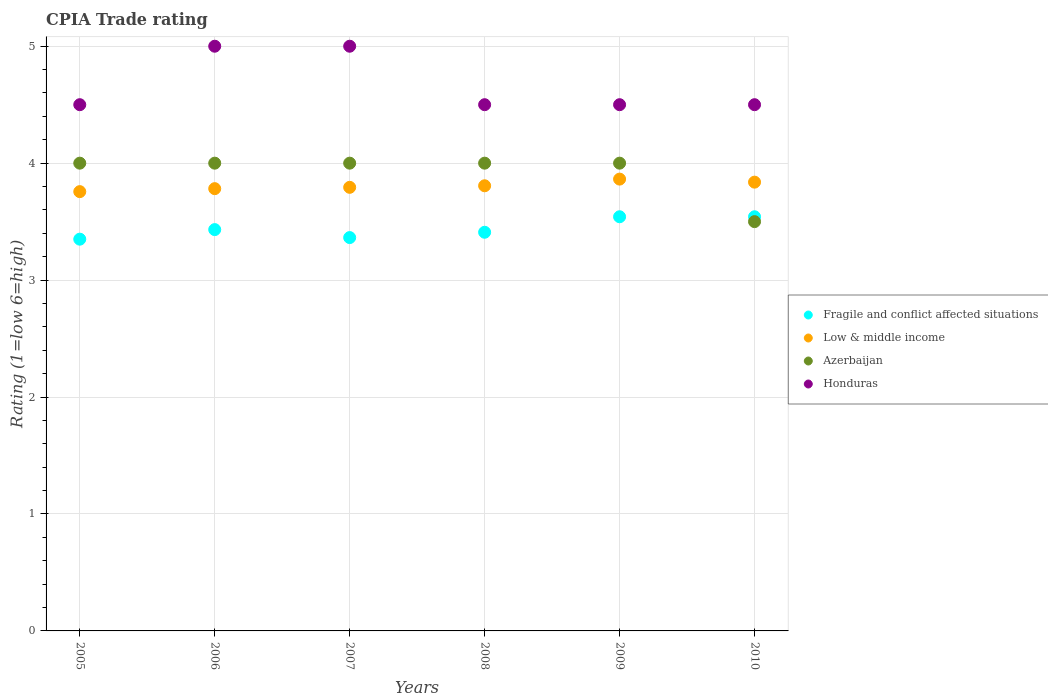How many different coloured dotlines are there?
Your answer should be very brief. 4. Is the number of dotlines equal to the number of legend labels?
Keep it short and to the point. Yes. Across all years, what is the maximum CPIA rating in Low & middle income?
Make the answer very short. 3.86. Across all years, what is the minimum CPIA rating in Low & middle income?
Your answer should be compact. 3.76. In which year was the CPIA rating in Fragile and conflict affected situations maximum?
Provide a succinct answer. 2009. What is the total CPIA rating in Low & middle income in the graph?
Provide a short and direct response. 22.84. What is the difference between the CPIA rating in Low & middle income in 2009 and that in 2010?
Offer a very short reply. 0.03. What is the difference between the CPIA rating in Azerbaijan in 2005 and the CPIA rating in Low & middle income in 2010?
Your answer should be very brief. 0.16. What is the average CPIA rating in Fragile and conflict affected situations per year?
Ensure brevity in your answer.  3.44. In the year 2008, what is the difference between the CPIA rating in Azerbaijan and CPIA rating in Honduras?
Keep it short and to the point. -0.5. What is the ratio of the CPIA rating in Low & middle income in 2006 to that in 2010?
Provide a succinct answer. 0.99. Is the CPIA rating in Low & middle income in 2008 less than that in 2009?
Your answer should be very brief. Yes. Is the difference between the CPIA rating in Azerbaijan in 2006 and 2007 greater than the difference between the CPIA rating in Honduras in 2006 and 2007?
Provide a succinct answer. No. In how many years, is the CPIA rating in Low & middle income greater than the average CPIA rating in Low & middle income taken over all years?
Provide a short and direct response. 3. Is it the case that in every year, the sum of the CPIA rating in Honduras and CPIA rating in Azerbaijan  is greater than the sum of CPIA rating in Fragile and conflict affected situations and CPIA rating in Low & middle income?
Keep it short and to the point. No. Is it the case that in every year, the sum of the CPIA rating in Fragile and conflict affected situations and CPIA rating in Azerbaijan  is greater than the CPIA rating in Honduras?
Make the answer very short. Yes. Does the CPIA rating in Honduras monotonically increase over the years?
Provide a short and direct response. No. How many dotlines are there?
Your answer should be very brief. 4. How many years are there in the graph?
Your answer should be very brief. 6. What is the difference between two consecutive major ticks on the Y-axis?
Ensure brevity in your answer.  1. How many legend labels are there?
Provide a succinct answer. 4. How are the legend labels stacked?
Your answer should be very brief. Vertical. What is the title of the graph?
Keep it short and to the point. CPIA Trade rating. Does "Denmark" appear as one of the legend labels in the graph?
Offer a terse response. No. What is the Rating (1=low 6=high) in Fragile and conflict affected situations in 2005?
Ensure brevity in your answer.  3.35. What is the Rating (1=low 6=high) of Low & middle income in 2005?
Your answer should be compact. 3.76. What is the Rating (1=low 6=high) in Azerbaijan in 2005?
Your answer should be compact. 4. What is the Rating (1=low 6=high) of Honduras in 2005?
Your answer should be compact. 4.5. What is the Rating (1=low 6=high) of Fragile and conflict affected situations in 2006?
Offer a very short reply. 3.43. What is the Rating (1=low 6=high) in Low & middle income in 2006?
Provide a succinct answer. 3.78. What is the Rating (1=low 6=high) of Honduras in 2006?
Provide a succinct answer. 5. What is the Rating (1=low 6=high) of Fragile and conflict affected situations in 2007?
Your answer should be very brief. 3.36. What is the Rating (1=low 6=high) in Low & middle income in 2007?
Your answer should be very brief. 3.79. What is the Rating (1=low 6=high) of Honduras in 2007?
Your answer should be compact. 5. What is the Rating (1=low 6=high) in Fragile and conflict affected situations in 2008?
Offer a terse response. 3.41. What is the Rating (1=low 6=high) of Low & middle income in 2008?
Provide a short and direct response. 3.81. What is the Rating (1=low 6=high) of Azerbaijan in 2008?
Ensure brevity in your answer.  4. What is the Rating (1=low 6=high) in Honduras in 2008?
Keep it short and to the point. 4.5. What is the Rating (1=low 6=high) of Fragile and conflict affected situations in 2009?
Provide a succinct answer. 3.54. What is the Rating (1=low 6=high) in Low & middle income in 2009?
Give a very brief answer. 3.86. What is the Rating (1=low 6=high) in Azerbaijan in 2009?
Keep it short and to the point. 4. What is the Rating (1=low 6=high) in Fragile and conflict affected situations in 2010?
Ensure brevity in your answer.  3.54. What is the Rating (1=low 6=high) in Low & middle income in 2010?
Ensure brevity in your answer.  3.84. What is the Rating (1=low 6=high) in Azerbaijan in 2010?
Give a very brief answer. 3.5. Across all years, what is the maximum Rating (1=low 6=high) in Fragile and conflict affected situations?
Give a very brief answer. 3.54. Across all years, what is the maximum Rating (1=low 6=high) of Low & middle income?
Your response must be concise. 3.86. Across all years, what is the maximum Rating (1=low 6=high) of Azerbaijan?
Your answer should be very brief. 4. Across all years, what is the minimum Rating (1=low 6=high) of Fragile and conflict affected situations?
Make the answer very short. 3.35. Across all years, what is the minimum Rating (1=low 6=high) of Low & middle income?
Make the answer very short. 3.76. Across all years, what is the minimum Rating (1=low 6=high) in Azerbaijan?
Ensure brevity in your answer.  3.5. Across all years, what is the minimum Rating (1=low 6=high) in Honduras?
Your answer should be very brief. 4.5. What is the total Rating (1=low 6=high) of Fragile and conflict affected situations in the graph?
Offer a terse response. 20.64. What is the total Rating (1=low 6=high) of Low & middle income in the graph?
Provide a short and direct response. 22.84. What is the total Rating (1=low 6=high) in Azerbaijan in the graph?
Provide a succinct answer. 23.5. What is the total Rating (1=low 6=high) in Honduras in the graph?
Your answer should be compact. 28. What is the difference between the Rating (1=low 6=high) in Fragile and conflict affected situations in 2005 and that in 2006?
Provide a short and direct response. -0.08. What is the difference between the Rating (1=low 6=high) in Low & middle income in 2005 and that in 2006?
Make the answer very short. -0.03. What is the difference between the Rating (1=low 6=high) of Azerbaijan in 2005 and that in 2006?
Provide a short and direct response. 0. What is the difference between the Rating (1=low 6=high) of Fragile and conflict affected situations in 2005 and that in 2007?
Your answer should be compact. -0.01. What is the difference between the Rating (1=low 6=high) in Low & middle income in 2005 and that in 2007?
Ensure brevity in your answer.  -0.04. What is the difference between the Rating (1=low 6=high) in Honduras in 2005 and that in 2007?
Provide a succinct answer. -0.5. What is the difference between the Rating (1=low 6=high) of Fragile and conflict affected situations in 2005 and that in 2008?
Offer a very short reply. -0.06. What is the difference between the Rating (1=low 6=high) in Low & middle income in 2005 and that in 2008?
Offer a terse response. -0.05. What is the difference between the Rating (1=low 6=high) in Honduras in 2005 and that in 2008?
Make the answer very short. 0. What is the difference between the Rating (1=low 6=high) of Fragile and conflict affected situations in 2005 and that in 2009?
Give a very brief answer. -0.19. What is the difference between the Rating (1=low 6=high) in Low & middle income in 2005 and that in 2009?
Offer a very short reply. -0.11. What is the difference between the Rating (1=low 6=high) of Azerbaijan in 2005 and that in 2009?
Offer a very short reply. 0. What is the difference between the Rating (1=low 6=high) of Fragile and conflict affected situations in 2005 and that in 2010?
Your answer should be compact. -0.19. What is the difference between the Rating (1=low 6=high) of Low & middle income in 2005 and that in 2010?
Your response must be concise. -0.08. What is the difference between the Rating (1=low 6=high) in Azerbaijan in 2005 and that in 2010?
Provide a short and direct response. 0.5. What is the difference between the Rating (1=low 6=high) of Fragile and conflict affected situations in 2006 and that in 2007?
Give a very brief answer. 0.07. What is the difference between the Rating (1=low 6=high) of Low & middle income in 2006 and that in 2007?
Your response must be concise. -0.01. What is the difference between the Rating (1=low 6=high) of Azerbaijan in 2006 and that in 2007?
Your answer should be very brief. 0. What is the difference between the Rating (1=low 6=high) in Honduras in 2006 and that in 2007?
Ensure brevity in your answer.  0. What is the difference between the Rating (1=low 6=high) of Fragile and conflict affected situations in 2006 and that in 2008?
Offer a very short reply. 0.02. What is the difference between the Rating (1=low 6=high) in Low & middle income in 2006 and that in 2008?
Offer a very short reply. -0.02. What is the difference between the Rating (1=low 6=high) of Fragile and conflict affected situations in 2006 and that in 2009?
Your response must be concise. -0.11. What is the difference between the Rating (1=low 6=high) of Low & middle income in 2006 and that in 2009?
Ensure brevity in your answer.  -0.08. What is the difference between the Rating (1=low 6=high) in Azerbaijan in 2006 and that in 2009?
Offer a very short reply. 0. What is the difference between the Rating (1=low 6=high) of Fragile and conflict affected situations in 2006 and that in 2010?
Make the answer very short. -0.11. What is the difference between the Rating (1=low 6=high) in Low & middle income in 2006 and that in 2010?
Offer a very short reply. -0.06. What is the difference between the Rating (1=low 6=high) of Azerbaijan in 2006 and that in 2010?
Offer a terse response. 0.5. What is the difference between the Rating (1=low 6=high) in Honduras in 2006 and that in 2010?
Provide a succinct answer. 0.5. What is the difference between the Rating (1=low 6=high) in Fragile and conflict affected situations in 2007 and that in 2008?
Your answer should be very brief. -0.05. What is the difference between the Rating (1=low 6=high) of Low & middle income in 2007 and that in 2008?
Your response must be concise. -0.01. What is the difference between the Rating (1=low 6=high) in Fragile and conflict affected situations in 2007 and that in 2009?
Offer a terse response. -0.18. What is the difference between the Rating (1=low 6=high) in Low & middle income in 2007 and that in 2009?
Your response must be concise. -0.07. What is the difference between the Rating (1=low 6=high) of Azerbaijan in 2007 and that in 2009?
Provide a short and direct response. 0. What is the difference between the Rating (1=low 6=high) of Honduras in 2007 and that in 2009?
Offer a terse response. 0.5. What is the difference between the Rating (1=low 6=high) in Fragile and conflict affected situations in 2007 and that in 2010?
Offer a terse response. -0.18. What is the difference between the Rating (1=low 6=high) in Low & middle income in 2007 and that in 2010?
Make the answer very short. -0.04. What is the difference between the Rating (1=low 6=high) in Fragile and conflict affected situations in 2008 and that in 2009?
Provide a short and direct response. -0.13. What is the difference between the Rating (1=low 6=high) in Low & middle income in 2008 and that in 2009?
Offer a terse response. -0.06. What is the difference between the Rating (1=low 6=high) in Azerbaijan in 2008 and that in 2009?
Keep it short and to the point. 0. What is the difference between the Rating (1=low 6=high) in Fragile and conflict affected situations in 2008 and that in 2010?
Keep it short and to the point. -0.13. What is the difference between the Rating (1=low 6=high) of Low & middle income in 2008 and that in 2010?
Offer a terse response. -0.03. What is the difference between the Rating (1=low 6=high) in Fragile and conflict affected situations in 2009 and that in 2010?
Offer a terse response. 0. What is the difference between the Rating (1=low 6=high) in Low & middle income in 2009 and that in 2010?
Offer a terse response. 0.03. What is the difference between the Rating (1=low 6=high) in Fragile and conflict affected situations in 2005 and the Rating (1=low 6=high) in Low & middle income in 2006?
Keep it short and to the point. -0.43. What is the difference between the Rating (1=low 6=high) of Fragile and conflict affected situations in 2005 and the Rating (1=low 6=high) of Azerbaijan in 2006?
Offer a very short reply. -0.65. What is the difference between the Rating (1=low 6=high) of Fragile and conflict affected situations in 2005 and the Rating (1=low 6=high) of Honduras in 2006?
Your answer should be compact. -1.65. What is the difference between the Rating (1=low 6=high) of Low & middle income in 2005 and the Rating (1=low 6=high) of Azerbaijan in 2006?
Your answer should be compact. -0.24. What is the difference between the Rating (1=low 6=high) of Low & middle income in 2005 and the Rating (1=low 6=high) of Honduras in 2006?
Offer a very short reply. -1.24. What is the difference between the Rating (1=low 6=high) of Azerbaijan in 2005 and the Rating (1=low 6=high) of Honduras in 2006?
Provide a short and direct response. -1. What is the difference between the Rating (1=low 6=high) of Fragile and conflict affected situations in 2005 and the Rating (1=low 6=high) of Low & middle income in 2007?
Ensure brevity in your answer.  -0.44. What is the difference between the Rating (1=low 6=high) of Fragile and conflict affected situations in 2005 and the Rating (1=low 6=high) of Azerbaijan in 2007?
Provide a short and direct response. -0.65. What is the difference between the Rating (1=low 6=high) in Fragile and conflict affected situations in 2005 and the Rating (1=low 6=high) in Honduras in 2007?
Your response must be concise. -1.65. What is the difference between the Rating (1=low 6=high) of Low & middle income in 2005 and the Rating (1=low 6=high) of Azerbaijan in 2007?
Keep it short and to the point. -0.24. What is the difference between the Rating (1=low 6=high) of Low & middle income in 2005 and the Rating (1=low 6=high) of Honduras in 2007?
Provide a short and direct response. -1.24. What is the difference between the Rating (1=low 6=high) in Azerbaijan in 2005 and the Rating (1=low 6=high) in Honduras in 2007?
Your response must be concise. -1. What is the difference between the Rating (1=low 6=high) of Fragile and conflict affected situations in 2005 and the Rating (1=low 6=high) of Low & middle income in 2008?
Provide a short and direct response. -0.46. What is the difference between the Rating (1=low 6=high) of Fragile and conflict affected situations in 2005 and the Rating (1=low 6=high) of Azerbaijan in 2008?
Make the answer very short. -0.65. What is the difference between the Rating (1=low 6=high) in Fragile and conflict affected situations in 2005 and the Rating (1=low 6=high) in Honduras in 2008?
Offer a very short reply. -1.15. What is the difference between the Rating (1=low 6=high) in Low & middle income in 2005 and the Rating (1=low 6=high) in Azerbaijan in 2008?
Offer a terse response. -0.24. What is the difference between the Rating (1=low 6=high) of Low & middle income in 2005 and the Rating (1=low 6=high) of Honduras in 2008?
Your answer should be very brief. -0.74. What is the difference between the Rating (1=low 6=high) in Azerbaijan in 2005 and the Rating (1=low 6=high) in Honduras in 2008?
Ensure brevity in your answer.  -0.5. What is the difference between the Rating (1=low 6=high) in Fragile and conflict affected situations in 2005 and the Rating (1=low 6=high) in Low & middle income in 2009?
Make the answer very short. -0.51. What is the difference between the Rating (1=low 6=high) of Fragile and conflict affected situations in 2005 and the Rating (1=low 6=high) of Azerbaijan in 2009?
Your response must be concise. -0.65. What is the difference between the Rating (1=low 6=high) in Fragile and conflict affected situations in 2005 and the Rating (1=low 6=high) in Honduras in 2009?
Provide a short and direct response. -1.15. What is the difference between the Rating (1=low 6=high) in Low & middle income in 2005 and the Rating (1=low 6=high) in Azerbaijan in 2009?
Your response must be concise. -0.24. What is the difference between the Rating (1=low 6=high) in Low & middle income in 2005 and the Rating (1=low 6=high) in Honduras in 2009?
Offer a very short reply. -0.74. What is the difference between the Rating (1=low 6=high) in Azerbaijan in 2005 and the Rating (1=low 6=high) in Honduras in 2009?
Provide a succinct answer. -0.5. What is the difference between the Rating (1=low 6=high) in Fragile and conflict affected situations in 2005 and the Rating (1=low 6=high) in Low & middle income in 2010?
Ensure brevity in your answer.  -0.49. What is the difference between the Rating (1=low 6=high) of Fragile and conflict affected situations in 2005 and the Rating (1=low 6=high) of Honduras in 2010?
Keep it short and to the point. -1.15. What is the difference between the Rating (1=low 6=high) of Low & middle income in 2005 and the Rating (1=low 6=high) of Azerbaijan in 2010?
Give a very brief answer. 0.26. What is the difference between the Rating (1=low 6=high) in Low & middle income in 2005 and the Rating (1=low 6=high) in Honduras in 2010?
Provide a short and direct response. -0.74. What is the difference between the Rating (1=low 6=high) in Fragile and conflict affected situations in 2006 and the Rating (1=low 6=high) in Low & middle income in 2007?
Make the answer very short. -0.36. What is the difference between the Rating (1=low 6=high) in Fragile and conflict affected situations in 2006 and the Rating (1=low 6=high) in Azerbaijan in 2007?
Make the answer very short. -0.57. What is the difference between the Rating (1=low 6=high) of Fragile and conflict affected situations in 2006 and the Rating (1=low 6=high) of Honduras in 2007?
Keep it short and to the point. -1.57. What is the difference between the Rating (1=low 6=high) in Low & middle income in 2006 and the Rating (1=low 6=high) in Azerbaijan in 2007?
Offer a terse response. -0.22. What is the difference between the Rating (1=low 6=high) in Low & middle income in 2006 and the Rating (1=low 6=high) in Honduras in 2007?
Provide a short and direct response. -1.22. What is the difference between the Rating (1=low 6=high) in Azerbaijan in 2006 and the Rating (1=low 6=high) in Honduras in 2007?
Keep it short and to the point. -1. What is the difference between the Rating (1=low 6=high) of Fragile and conflict affected situations in 2006 and the Rating (1=low 6=high) of Low & middle income in 2008?
Your response must be concise. -0.37. What is the difference between the Rating (1=low 6=high) of Fragile and conflict affected situations in 2006 and the Rating (1=low 6=high) of Azerbaijan in 2008?
Give a very brief answer. -0.57. What is the difference between the Rating (1=low 6=high) in Fragile and conflict affected situations in 2006 and the Rating (1=low 6=high) in Honduras in 2008?
Offer a very short reply. -1.07. What is the difference between the Rating (1=low 6=high) in Low & middle income in 2006 and the Rating (1=low 6=high) in Azerbaijan in 2008?
Your response must be concise. -0.22. What is the difference between the Rating (1=low 6=high) in Low & middle income in 2006 and the Rating (1=low 6=high) in Honduras in 2008?
Offer a very short reply. -0.72. What is the difference between the Rating (1=low 6=high) in Azerbaijan in 2006 and the Rating (1=low 6=high) in Honduras in 2008?
Give a very brief answer. -0.5. What is the difference between the Rating (1=low 6=high) in Fragile and conflict affected situations in 2006 and the Rating (1=low 6=high) in Low & middle income in 2009?
Give a very brief answer. -0.43. What is the difference between the Rating (1=low 6=high) in Fragile and conflict affected situations in 2006 and the Rating (1=low 6=high) in Azerbaijan in 2009?
Keep it short and to the point. -0.57. What is the difference between the Rating (1=low 6=high) in Fragile and conflict affected situations in 2006 and the Rating (1=low 6=high) in Honduras in 2009?
Your response must be concise. -1.07. What is the difference between the Rating (1=low 6=high) of Low & middle income in 2006 and the Rating (1=low 6=high) of Azerbaijan in 2009?
Provide a short and direct response. -0.22. What is the difference between the Rating (1=low 6=high) in Low & middle income in 2006 and the Rating (1=low 6=high) in Honduras in 2009?
Ensure brevity in your answer.  -0.72. What is the difference between the Rating (1=low 6=high) in Azerbaijan in 2006 and the Rating (1=low 6=high) in Honduras in 2009?
Your answer should be very brief. -0.5. What is the difference between the Rating (1=low 6=high) of Fragile and conflict affected situations in 2006 and the Rating (1=low 6=high) of Low & middle income in 2010?
Offer a very short reply. -0.41. What is the difference between the Rating (1=low 6=high) in Fragile and conflict affected situations in 2006 and the Rating (1=low 6=high) in Azerbaijan in 2010?
Make the answer very short. -0.07. What is the difference between the Rating (1=low 6=high) of Fragile and conflict affected situations in 2006 and the Rating (1=low 6=high) of Honduras in 2010?
Give a very brief answer. -1.07. What is the difference between the Rating (1=low 6=high) in Low & middle income in 2006 and the Rating (1=low 6=high) in Azerbaijan in 2010?
Ensure brevity in your answer.  0.28. What is the difference between the Rating (1=low 6=high) of Low & middle income in 2006 and the Rating (1=low 6=high) of Honduras in 2010?
Offer a very short reply. -0.72. What is the difference between the Rating (1=low 6=high) in Azerbaijan in 2006 and the Rating (1=low 6=high) in Honduras in 2010?
Offer a very short reply. -0.5. What is the difference between the Rating (1=low 6=high) in Fragile and conflict affected situations in 2007 and the Rating (1=low 6=high) in Low & middle income in 2008?
Your response must be concise. -0.44. What is the difference between the Rating (1=low 6=high) in Fragile and conflict affected situations in 2007 and the Rating (1=low 6=high) in Azerbaijan in 2008?
Your answer should be very brief. -0.64. What is the difference between the Rating (1=low 6=high) of Fragile and conflict affected situations in 2007 and the Rating (1=low 6=high) of Honduras in 2008?
Make the answer very short. -1.14. What is the difference between the Rating (1=low 6=high) in Low & middle income in 2007 and the Rating (1=low 6=high) in Azerbaijan in 2008?
Give a very brief answer. -0.21. What is the difference between the Rating (1=low 6=high) in Low & middle income in 2007 and the Rating (1=low 6=high) in Honduras in 2008?
Your answer should be compact. -0.71. What is the difference between the Rating (1=low 6=high) of Azerbaijan in 2007 and the Rating (1=low 6=high) of Honduras in 2008?
Provide a succinct answer. -0.5. What is the difference between the Rating (1=low 6=high) in Fragile and conflict affected situations in 2007 and the Rating (1=low 6=high) in Azerbaijan in 2009?
Your answer should be very brief. -0.64. What is the difference between the Rating (1=low 6=high) of Fragile and conflict affected situations in 2007 and the Rating (1=low 6=high) of Honduras in 2009?
Offer a terse response. -1.14. What is the difference between the Rating (1=low 6=high) of Low & middle income in 2007 and the Rating (1=low 6=high) of Azerbaijan in 2009?
Your answer should be very brief. -0.21. What is the difference between the Rating (1=low 6=high) in Low & middle income in 2007 and the Rating (1=low 6=high) in Honduras in 2009?
Ensure brevity in your answer.  -0.71. What is the difference between the Rating (1=low 6=high) in Fragile and conflict affected situations in 2007 and the Rating (1=low 6=high) in Low & middle income in 2010?
Provide a succinct answer. -0.47. What is the difference between the Rating (1=low 6=high) of Fragile and conflict affected situations in 2007 and the Rating (1=low 6=high) of Azerbaijan in 2010?
Offer a terse response. -0.14. What is the difference between the Rating (1=low 6=high) of Fragile and conflict affected situations in 2007 and the Rating (1=low 6=high) of Honduras in 2010?
Offer a very short reply. -1.14. What is the difference between the Rating (1=low 6=high) in Low & middle income in 2007 and the Rating (1=low 6=high) in Azerbaijan in 2010?
Make the answer very short. 0.29. What is the difference between the Rating (1=low 6=high) in Low & middle income in 2007 and the Rating (1=low 6=high) in Honduras in 2010?
Your response must be concise. -0.71. What is the difference between the Rating (1=low 6=high) of Azerbaijan in 2007 and the Rating (1=low 6=high) of Honduras in 2010?
Offer a very short reply. -0.5. What is the difference between the Rating (1=low 6=high) of Fragile and conflict affected situations in 2008 and the Rating (1=low 6=high) of Low & middle income in 2009?
Ensure brevity in your answer.  -0.45. What is the difference between the Rating (1=low 6=high) of Fragile and conflict affected situations in 2008 and the Rating (1=low 6=high) of Azerbaijan in 2009?
Give a very brief answer. -0.59. What is the difference between the Rating (1=low 6=high) in Fragile and conflict affected situations in 2008 and the Rating (1=low 6=high) in Honduras in 2009?
Provide a succinct answer. -1.09. What is the difference between the Rating (1=low 6=high) of Low & middle income in 2008 and the Rating (1=low 6=high) of Azerbaijan in 2009?
Give a very brief answer. -0.19. What is the difference between the Rating (1=low 6=high) in Low & middle income in 2008 and the Rating (1=low 6=high) in Honduras in 2009?
Make the answer very short. -0.69. What is the difference between the Rating (1=low 6=high) in Fragile and conflict affected situations in 2008 and the Rating (1=low 6=high) in Low & middle income in 2010?
Ensure brevity in your answer.  -0.43. What is the difference between the Rating (1=low 6=high) in Fragile and conflict affected situations in 2008 and the Rating (1=low 6=high) in Azerbaijan in 2010?
Your answer should be compact. -0.09. What is the difference between the Rating (1=low 6=high) of Fragile and conflict affected situations in 2008 and the Rating (1=low 6=high) of Honduras in 2010?
Provide a succinct answer. -1.09. What is the difference between the Rating (1=low 6=high) in Low & middle income in 2008 and the Rating (1=low 6=high) in Azerbaijan in 2010?
Offer a very short reply. 0.31. What is the difference between the Rating (1=low 6=high) of Low & middle income in 2008 and the Rating (1=low 6=high) of Honduras in 2010?
Your answer should be very brief. -0.69. What is the difference between the Rating (1=low 6=high) in Azerbaijan in 2008 and the Rating (1=low 6=high) in Honduras in 2010?
Provide a short and direct response. -0.5. What is the difference between the Rating (1=low 6=high) in Fragile and conflict affected situations in 2009 and the Rating (1=low 6=high) in Low & middle income in 2010?
Provide a succinct answer. -0.3. What is the difference between the Rating (1=low 6=high) in Fragile and conflict affected situations in 2009 and the Rating (1=low 6=high) in Azerbaijan in 2010?
Give a very brief answer. 0.04. What is the difference between the Rating (1=low 6=high) of Fragile and conflict affected situations in 2009 and the Rating (1=low 6=high) of Honduras in 2010?
Your response must be concise. -0.96. What is the difference between the Rating (1=low 6=high) of Low & middle income in 2009 and the Rating (1=low 6=high) of Azerbaijan in 2010?
Ensure brevity in your answer.  0.36. What is the difference between the Rating (1=low 6=high) of Low & middle income in 2009 and the Rating (1=low 6=high) of Honduras in 2010?
Your response must be concise. -0.64. What is the average Rating (1=low 6=high) of Fragile and conflict affected situations per year?
Make the answer very short. 3.44. What is the average Rating (1=low 6=high) in Low & middle income per year?
Provide a short and direct response. 3.81. What is the average Rating (1=low 6=high) of Azerbaijan per year?
Offer a terse response. 3.92. What is the average Rating (1=low 6=high) of Honduras per year?
Your response must be concise. 4.67. In the year 2005, what is the difference between the Rating (1=low 6=high) of Fragile and conflict affected situations and Rating (1=low 6=high) of Low & middle income?
Provide a succinct answer. -0.41. In the year 2005, what is the difference between the Rating (1=low 6=high) of Fragile and conflict affected situations and Rating (1=low 6=high) of Azerbaijan?
Keep it short and to the point. -0.65. In the year 2005, what is the difference between the Rating (1=low 6=high) in Fragile and conflict affected situations and Rating (1=low 6=high) in Honduras?
Provide a short and direct response. -1.15. In the year 2005, what is the difference between the Rating (1=low 6=high) in Low & middle income and Rating (1=low 6=high) in Azerbaijan?
Offer a terse response. -0.24. In the year 2005, what is the difference between the Rating (1=low 6=high) of Low & middle income and Rating (1=low 6=high) of Honduras?
Offer a very short reply. -0.74. In the year 2005, what is the difference between the Rating (1=low 6=high) in Azerbaijan and Rating (1=low 6=high) in Honduras?
Your response must be concise. -0.5. In the year 2006, what is the difference between the Rating (1=low 6=high) of Fragile and conflict affected situations and Rating (1=low 6=high) of Low & middle income?
Provide a succinct answer. -0.35. In the year 2006, what is the difference between the Rating (1=low 6=high) of Fragile and conflict affected situations and Rating (1=low 6=high) of Azerbaijan?
Give a very brief answer. -0.57. In the year 2006, what is the difference between the Rating (1=low 6=high) of Fragile and conflict affected situations and Rating (1=low 6=high) of Honduras?
Give a very brief answer. -1.57. In the year 2006, what is the difference between the Rating (1=low 6=high) in Low & middle income and Rating (1=low 6=high) in Azerbaijan?
Your answer should be very brief. -0.22. In the year 2006, what is the difference between the Rating (1=low 6=high) in Low & middle income and Rating (1=low 6=high) in Honduras?
Provide a succinct answer. -1.22. In the year 2007, what is the difference between the Rating (1=low 6=high) in Fragile and conflict affected situations and Rating (1=low 6=high) in Low & middle income?
Provide a short and direct response. -0.43. In the year 2007, what is the difference between the Rating (1=low 6=high) of Fragile and conflict affected situations and Rating (1=low 6=high) of Azerbaijan?
Ensure brevity in your answer.  -0.64. In the year 2007, what is the difference between the Rating (1=low 6=high) of Fragile and conflict affected situations and Rating (1=low 6=high) of Honduras?
Ensure brevity in your answer.  -1.64. In the year 2007, what is the difference between the Rating (1=low 6=high) of Low & middle income and Rating (1=low 6=high) of Azerbaijan?
Provide a succinct answer. -0.21. In the year 2007, what is the difference between the Rating (1=low 6=high) of Low & middle income and Rating (1=low 6=high) of Honduras?
Provide a succinct answer. -1.21. In the year 2008, what is the difference between the Rating (1=low 6=high) in Fragile and conflict affected situations and Rating (1=low 6=high) in Low & middle income?
Provide a short and direct response. -0.4. In the year 2008, what is the difference between the Rating (1=low 6=high) in Fragile and conflict affected situations and Rating (1=low 6=high) in Azerbaijan?
Offer a very short reply. -0.59. In the year 2008, what is the difference between the Rating (1=low 6=high) of Fragile and conflict affected situations and Rating (1=low 6=high) of Honduras?
Offer a very short reply. -1.09. In the year 2008, what is the difference between the Rating (1=low 6=high) of Low & middle income and Rating (1=low 6=high) of Azerbaijan?
Ensure brevity in your answer.  -0.19. In the year 2008, what is the difference between the Rating (1=low 6=high) in Low & middle income and Rating (1=low 6=high) in Honduras?
Offer a terse response. -0.69. In the year 2009, what is the difference between the Rating (1=low 6=high) in Fragile and conflict affected situations and Rating (1=low 6=high) in Low & middle income?
Provide a short and direct response. -0.32. In the year 2009, what is the difference between the Rating (1=low 6=high) of Fragile and conflict affected situations and Rating (1=low 6=high) of Azerbaijan?
Make the answer very short. -0.46. In the year 2009, what is the difference between the Rating (1=low 6=high) in Fragile and conflict affected situations and Rating (1=low 6=high) in Honduras?
Your answer should be very brief. -0.96. In the year 2009, what is the difference between the Rating (1=low 6=high) in Low & middle income and Rating (1=low 6=high) in Azerbaijan?
Give a very brief answer. -0.14. In the year 2009, what is the difference between the Rating (1=low 6=high) of Low & middle income and Rating (1=low 6=high) of Honduras?
Give a very brief answer. -0.64. In the year 2010, what is the difference between the Rating (1=low 6=high) of Fragile and conflict affected situations and Rating (1=low 6=high) of Low & middle income?
Your answer should be very brief. -0.3. In the year 2010, what is the difference between the Rating (1=low 6=high) in Fragile and conflict affected situations and Rating (1=low 6=high) in Azerbaijan?
Ensure brevity in your answer.  0.04. In the year 2010, what is the difference between the Rating (1=low 6=high) in Fragile and conflict affected situations and Rating (1=low 6=high) in Honduras?
Keep it short and to the point. -0.96. In the year 2010, what is the difference between the Rating (1=low 6=high) in Low & middle income and Rating (1=low 6=high) in Azerbaijan?
Your response must be concise. 0.34. In the year 2010, what is the difference between the Rating (1=low 6=high) in Low & middle income and Rating (1=low 6=high) in Honduras?
Offer a very short reply. -0.66. In the year 2010, what is the difference between the Rating (1=low 6=high) in Azerbaijan and Rating (1=low 6=high) in Honduras?
Your answer should be compact. -1. What is the ratio of the Rating (1=low 6=high) in Fragile and conflict affected situations in 2005 to that in 2006?
Your response must be concise. 0.98. What is the ratio of the Rating (1=low 6=high) in Low & middle income in 2005 to that in 2006?
Keep it short and to the point. 0.99. What is the ratio of the Rating (1=low 6=high) of Azerbaijan in 2005 to that in 2006?
Make the answer very short. 1. What is the ratio of the Rating (1=low 6=high) in Low & middle income in 2005 to that in 2007?
Your response must be concise. 0.99. What is the ratio of the Rating (1=low 6=high) in Azerbaijan in 2005 to that in 2007?
Provide a short and direct response. 1. What is the ratio of the Rating (1=low 6=high) of Honduras in 2005 to that in 2007?
Provide a succinct answer. 0.9. What is the ratio of the Rating (1=low 6=high) in Fragile and conflict affected situations in 2005 to that in 2008?
Your answer should be very brief. 0.98. What is the ratio of the Rating (1=low 6=high) in Low & middle income in 2005 to that in 2008?
Your answer should be very brief. 0.99. What is the ratio of the Rating (1=low 6=high) of Azerbaijan in 2005 to that in 2008?
Your answer should be compact. 1. What is the ratio of the Rating (1=low 6=high) of Fragile and conflict affected situations in 2005 to that in 2009?
Offer a very short reply. 0.95. What is the ratio of the Rating (1=low 6=high) in Low & middle income in 2005 to that in 2009?
Provide a short and direct response. 0.97. What is the ratio of the Rating (1=low 6=high) in Honduras in 2005 to that in 2009?
Give a very brief answer. 1. What is the ratio of the Rating (1=low 6=high) in Fragile and conflict affected situations in 2005 to that in 2010?
Your answer should be compact. 0.95. What is the ratio of the Rating (1=low 6=high) in Low & middle income in 2005 to that in 2010?
Ensure brevity in your answer.  0.98. What is the ratio of the Rating (1=low 6=high) of Azerbaijan in 2005 to that in 2010?
Give a very brief answer. 1.14. What is the ratio of the Rating (1=low 6=high) of Honduras in 2005 to that in 2010?
Make the answer very short. 1. What is the ratio of the Rating (1=low 6=high) of Fragile and conflict affected situations in 2006 to that in 2007?
Ensure brevity in your answer.  1.02. What is the ratio of the Rating (1=low 6=high) of Honduras in 2006 to that in 2007?
Offer a terse response. 1. What is the ratio of the Rating (1=low 6=high) in Fragile and conflict affected situations in 2006 to that in 2008?
Offer a very short reply. 1.01. What is the ratio of the Rating (1=low 6=high) of Low & middle income in 2006 to that in 2009?
Your response must be concise. 0.98. What is the ratio of the Rating (1=low 6=high) in Low & middle income in 2006 to that in 2010?
Provide a short and direct response. 0.99. What is the ratio of the Rating (1=low 6=high) in Fragile and conflict affected situations in 2007 to that in 2008?
Your answer should be compact. 0.99. What is the ratio of the Rating (1=low 6=high) of Fragile and conflict affected situations in 2007 to that in 2009?
Keep it short and to the point. 0.95. What is the ratio of the Rating (1=low 6=high) of Low & middle income in 2007 to that in 2009?
Your answer should be compact. 0.98. What is the ratio of the Rating (1=low 6=high) in Fragile and conflict affected situations in 2007 to that in 2010?
Offer a terse response. 0.95. What is the ratio of the Rating (1=low 6=high) in Low & middle income in 2007 to that in 2010?
Your answer should be very brief. 0.99. What is the ratio of the Rating (1=low 6=high) in Honduras in 2007 to that in 2010?
Your answer should be very brief. 1.11. What is the ratio of the Rating (1=low 6=high) in Fragile and conflict affected situations in 2008 to that in 2009?
Provide a succinct answer. 0.96. What is the ratio of the Rating (1=low 6=high) in Honduras in 2008 to that in 2009?
Your answer should be very brief. 1. What is the ratio of the Rating (1=low 6=high) in Fragile and conflict affected situations in 2008 to that in 2010?
Ensure brevity in your answer.  0.96. What is the ratio of the Rating (1=low 6=high) of Azerbaijan in 2008 to that in 2010?
Keep it short and to the point. 1.14. What is the ratio of the Rating (1=low 6=high) in Honduras in 2008 to that in 2010?
Offer a very short reply. 1. What is the ratio of the Rating (1=low 6=high) of Fragile and conflict affected situations in 2009 to that in 2010?
Offer a terse response. 1. What is the ratio of the Rating (1=low 6=high) in Low & middle income in 2009 to that in 2010?
Offer a very short reply. 1.01. What is the ratio of the Rating (1=low 6=high) of Honduras in 2009 to that in 2010?
Keep it short and to the point. 1. What is the difference between the highest and the second highest Rating (1=low 6=high) of Low & middle income?
Offer a terse response. 0.03. What is the difference between the highest and the lowest Rating (1=low 6=high) in Fragile and conflict affected situations?
Provide a short and direct response. 0.19. What is the difference between the highest and the lowest Rating (1=low 6=high) of Low & middle income?
Make the answer very short. 0.11. 